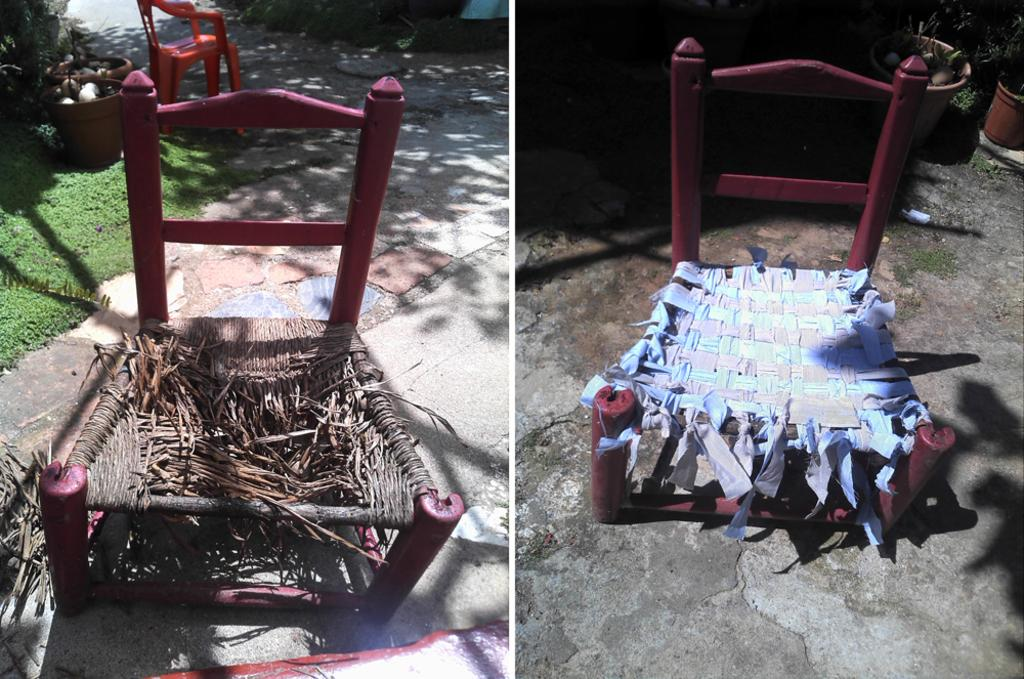What objects are located on the left side of the image? There are chairs, plant pots, stones, plants, and grass on the left side of the image. What objects are located on the right side of the image? There is a chair, plant pots, plants, and grass on the right side of the image. What type of vegetation is present in the image? There are plants and grass in the image. What type of star can be seen shining in the image? There is no star visible in the image. What type of sponge is being used to clean the plants in the image? There is no sponge present in the image, and the plants do not appear to be in need of cleaning. What type of zephyr is blowing through the image? There is no mention of a zephyr or any wind in the image. 